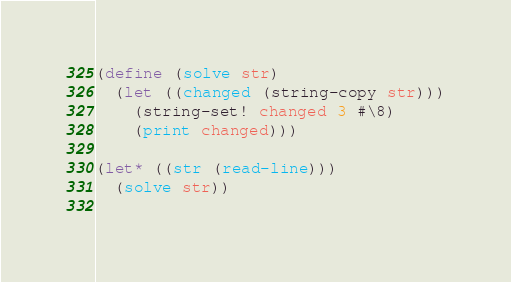Convert code to text. <code><loc_0><loc_0><loc_500><loc_500><_Scheme_>(define (solve str)
  (let ((changed (string-copy str)))
    (string-set! changed 3 #\8)
    (print changed)))

(let* ((str (read-line)))
  (solve str))
 
</code> 